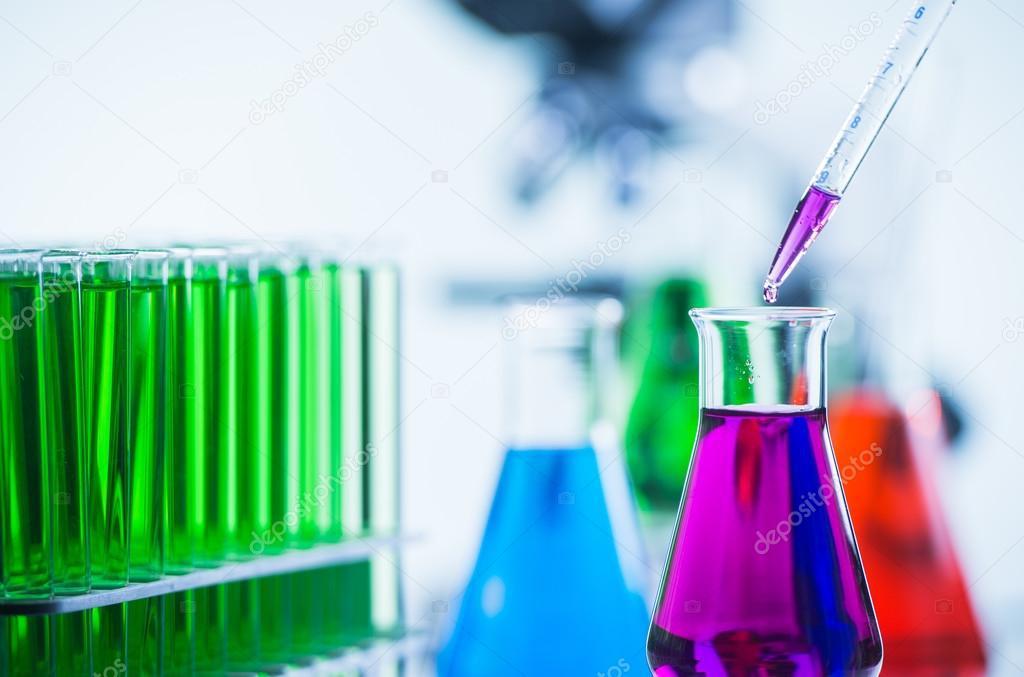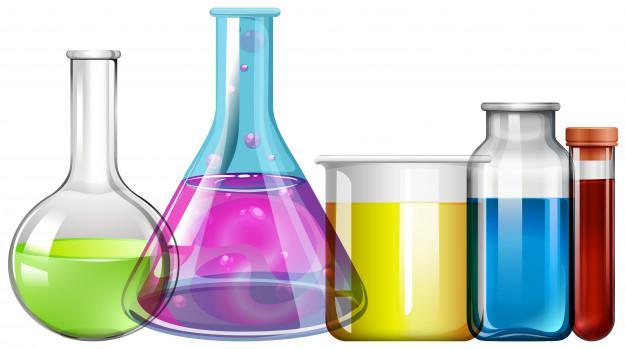The first image is the image on the left, the second image is the image on the right. Considering the images on both sides, is "Every image shows at least four containers of colored liquid and there are at least four different colors of liquid in each photo." valid? Answer yes or no. Yes. The first image is the image on the left, the second image is the image on the right. For the images shown, is this caption "One image shows a row of no more than five beakers displayed with their bases level, and each beaker contains a different color of liquid." true? Answer yes or no. Yes. 